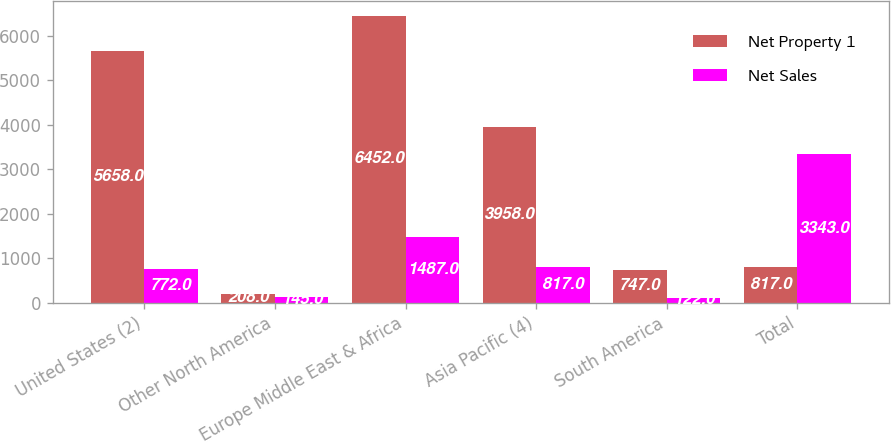Convert chart. <chart><loc_0><loc_0><loc_500><loc_500><stacked_bar_chart><ecel><fcel>United States (2)<fcel>Other North America<fcel>Europe Middle East & Africa<fcel>Asia Pacific (4)<fcel>South America<fcel>Total<nl><fcel>Net Property 1<fcel>5658<fcel>208<fcel>6452<fcel>3958<fcel>747<fcel>817<nl><fcel>Net Sales<fcel>772<fcel>145<fcel>1487<fcel>817<fcel>122<fcel>3343<nl></chart> 